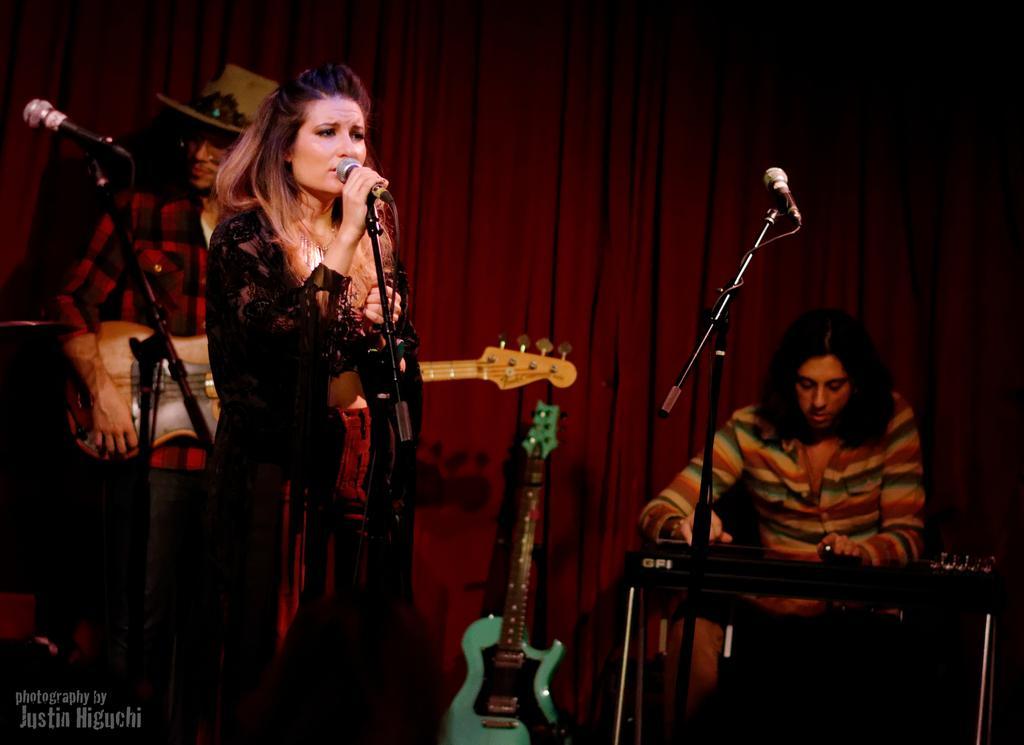In one or two sentences, can you explain what this image depicts? This is the woman standing and singing a song. These are the mics attached to the mike stands. Here is the man sitting and playing piano. This is a guitar which is green in color. I can see another person standing and playing guitar. This is the red color cloth hanging at the background. 